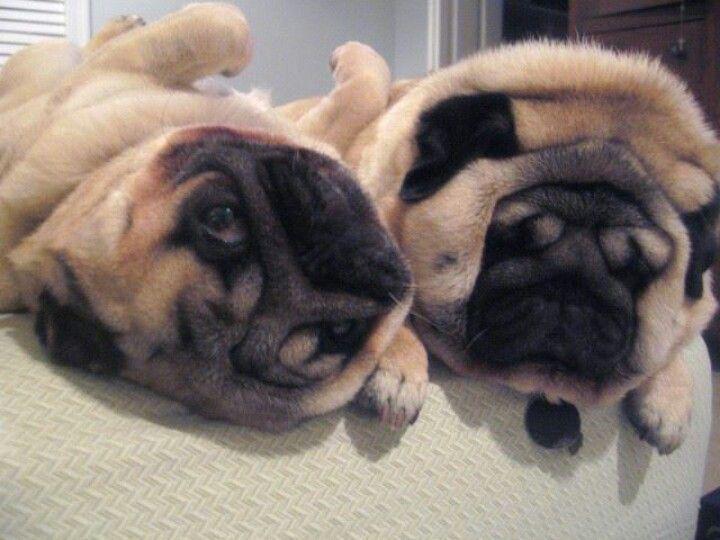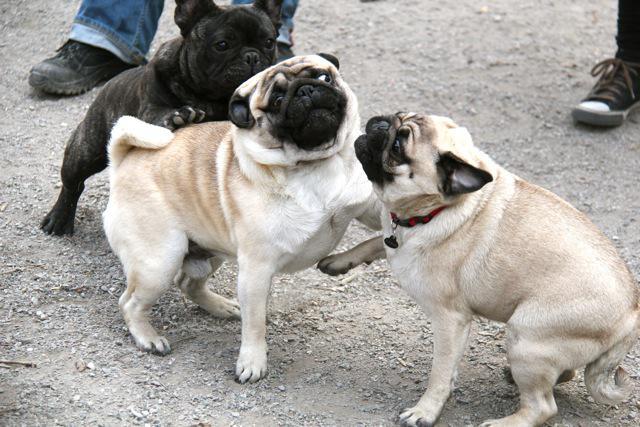The first image is the image on the left, the second image is the image on the right. Assess this claim about the two images: "There is exactly one pug in at least one image.". Correct or not? Answer yes or no. No. The first image is the image on the left, the second image is the image on the right. Analyze the images presented: Is the assertion "Each image in the pair has two pugs touching each other." valid? Answer yes or no. Yes. 